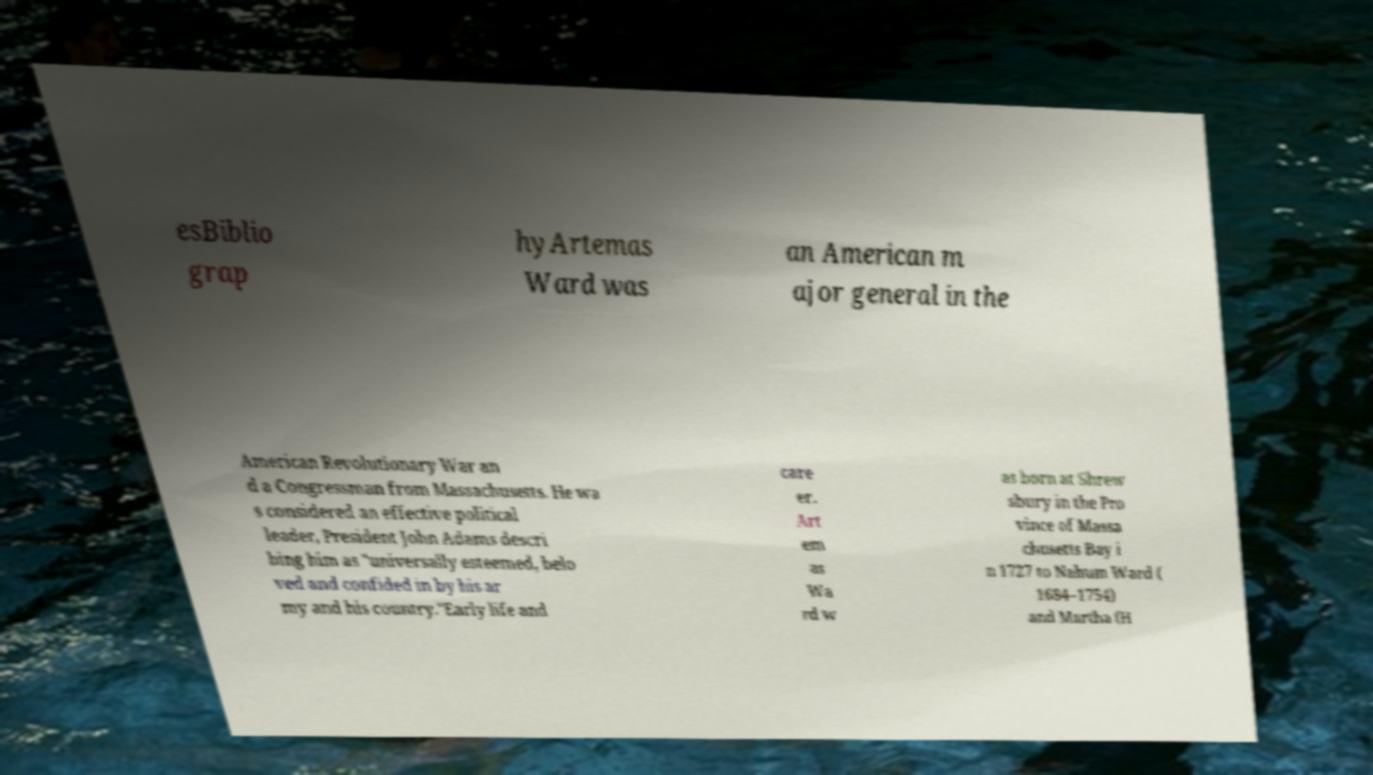Please identify and transcribe the text found in this image. esBiblio grap hyArtemas Ward was an American m ajor general in the American Revolutionary War an d a Congressman from Massachusetts. He wa s considered an effective political leader, President John Adams descri bing him as "universally esteemed, belo ved and confided in by his ar my and his country."Early life and care er. Art em as Wa rd w as born at Shrew sbury in the Pro vince of Massa chusetts Bay i n 1727 to Nahum Ward ( 1684–1754) and Martha (H 